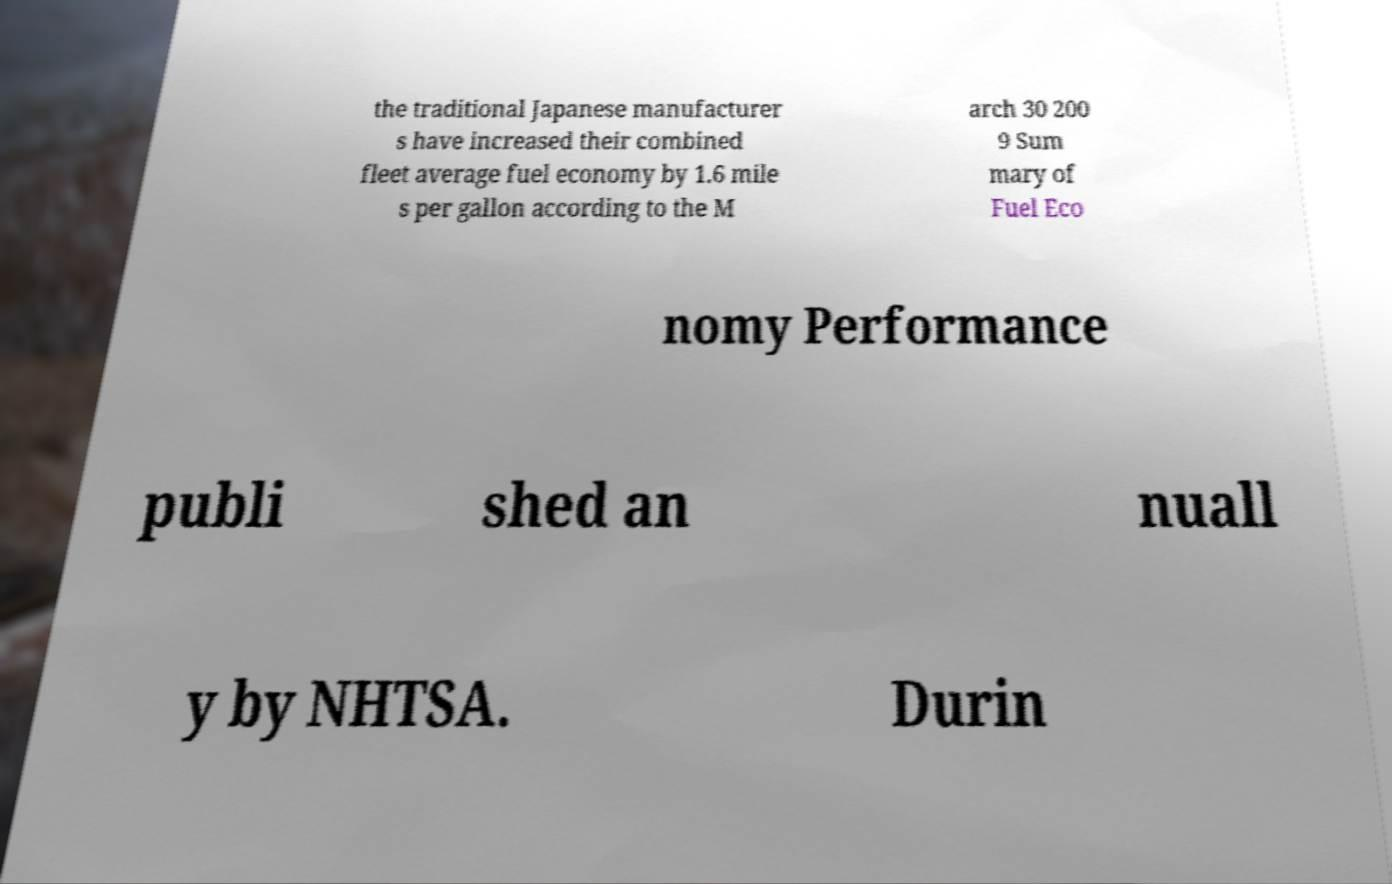For documentation purposes, I need the text within this image transcribed. Could you provide that? the traditional Japanese manufacturer s have increased their combined fleet average fuel economy by 1.6 mile s per gallon according to the M arch 30 200 9 Sum mary of Fuel Eco nomy Performance publi shed an nuall y by NHTSA. Durin 